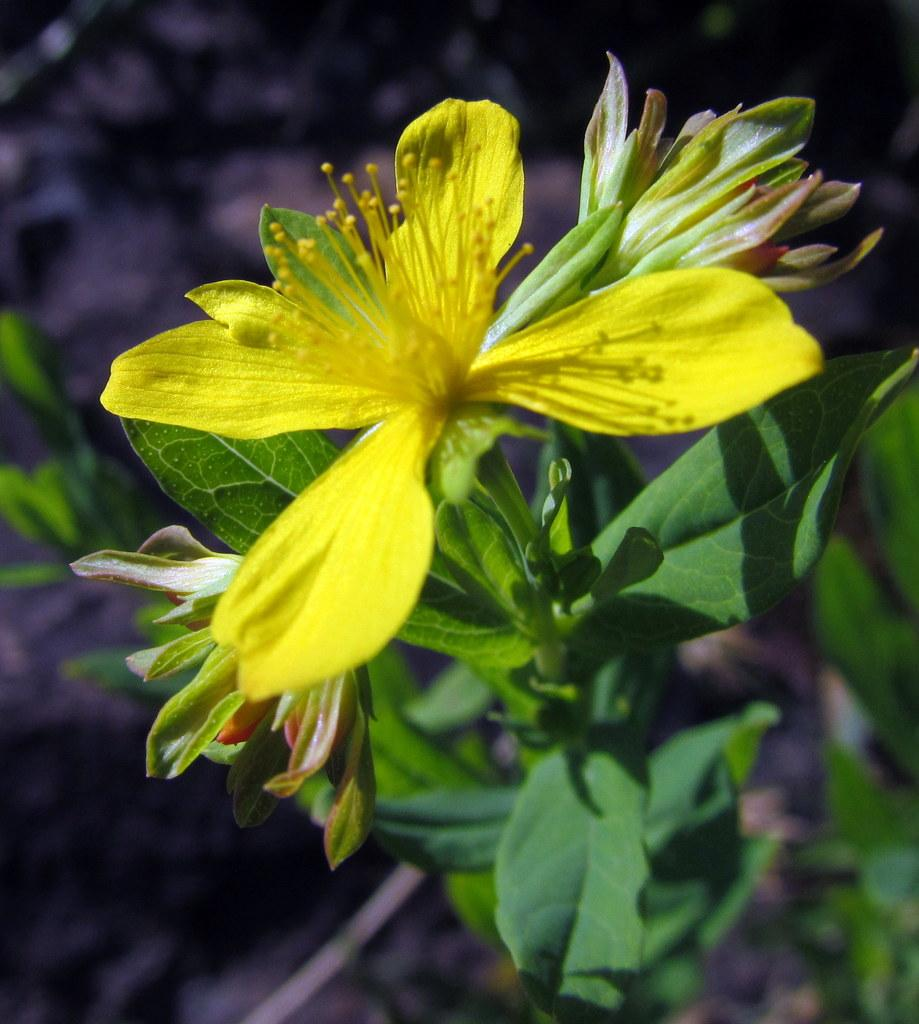What type of flower is in the image? There is a yellow flower in the image. Can you describe the flower's structure? The flower has a stem and leaves. What type of breakfast is being served in the image? There is no breakfast present in the image; it features a yellow flower with a stem and leaves. Can you tell me where the record is stored in the image? There is no record present in the image; it features a yellow flower with a stem and leaves. 